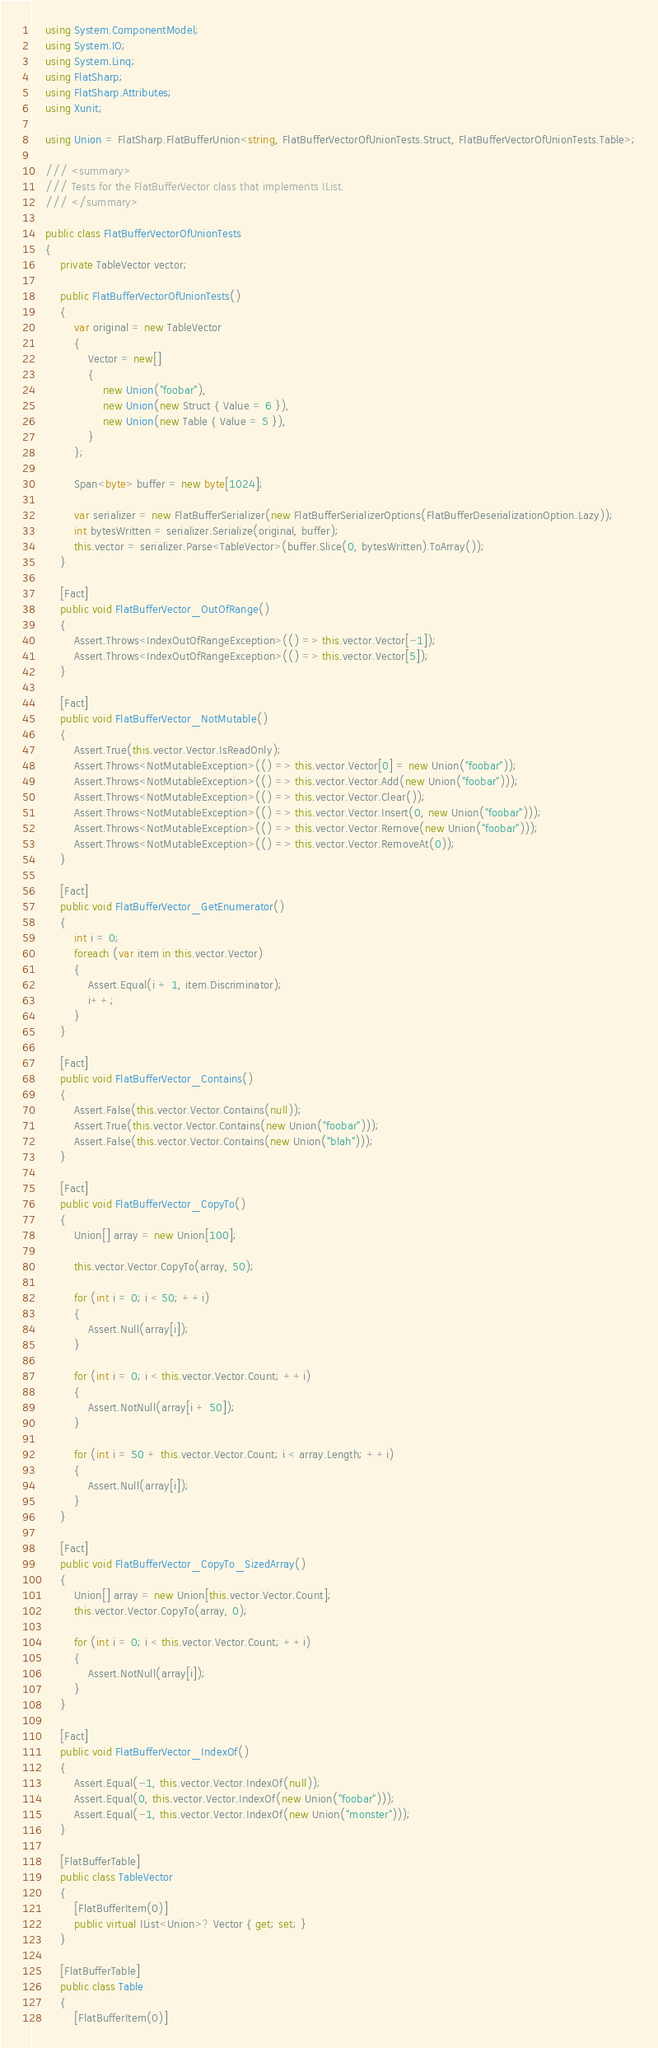<code> <loc_0><loc_0><loc_500><loc_500><_C#_>    using System.ComponentModel;
    using System.IO;
    using System.Linq;
    using FlatSharp;
    using FlatSharp.Attributes;
    using Xunit;

    using Union = FlatSharp.FlatBufferUnion<string, FlatBufferVectorOfUnionTests.Struct, FlatBufferVectorOfUnionTests.Table>;

    /// <summary>
    /// Tests for the FlatBufferVector class that implements IList.
    /// </summary>
    
    public class FlatBufferVectorOfUnionTests
    {
        private TableVector vector;

        public FlatBufferVectorOfUnionTests()
        {
            var original = new TableVector
            {
                Vector = new[]
                {
                    new Union("foobar"),
                    new Union(new Struct { Value = 6 }),
                    new Union(new Table { Value = 5 }),
                }
            };

            Span<byte> buffer = new byte[1024];

            var serializer = new FlatBufferSerializer(new FlatBufferSerializerOptions(FlatBufferDeserializationOption.Lazy));
            int bytesWritten = serializer.Serialize(original, buffer);
            this.vector = serializer.Parse<TableVector>(buffer.Slice(0, bytesWritten).ToArray());
        }

        [Fact]
        public void FlatBufferVector_OutOfRange()
        {
            Assert.Throws<IndexOutOfRangeException>(() => this.vector.Vector[-1]);
            Assert.Throws<IndexOutOfRangeException>(() => this.vector.Vector[5]);
        }

        [Fact]
        public void FlatBufferVector_NotMutable()
        {
            Assert.True(this.vector.Vector.IsReadOnly);
            Assert.Throws<NotMutableException>(() => this.vector.Vector[0] = new Union("foobar"));
            Assert.Throws<NotMutableException>(() => this.vector.Vector.Add(new Union("foobar")));
            Assert.Throws<NotMutableException>(() => this.vector.Vector.Clear());
            Assert.Throws<NotMutableException>(() => this.vector.Vector.Insert(0, new Union("foobar")));
            Assert.Throws<NotMutableException>(() => this.vector.Vector.Remove(new Union("foobar")));
            Assert.Throws<NotMutableException>(() => this.vector.Vector.RemoveAt(0));
        }

        [Fact]
        public void FlatBufferVector_GetEnumerator()
        {
            int i = 0; 
            foreach (var item in this.vector.Vector)
            {
                Assert.Equal(i + 1, item.Discriminator);
                i++;
            }
        }

        [Fact]
        public void FlatBufferVector_Contains()
        {
            Assert.False(this.vector.Vector.Contains(null));
            Assert.True(this.vector.Vector.Contains(new Union("foobar")));
            Assert.False(this.vector.Vector.Contains(new Union("blah")));
        }

        [Fact]
        public void FlatBufferVector_CopyTo()
        {
            Union[] array = new Union[100];

            this.vector.Vector.CopyTo(array, 50);
            
            for (int i = 0; i < 50; ++i)
            {
                Assert.Null(array[i]);
            }

            for (int i = 0; i < this.vector.Vector.Count; ++i)
            {
                Assert.NotNull(array[i + 50]);
            }

            for (int i = 50 + this.vector.Vector.Count; i < array.Length; ++i)
            {
                Assert.Null(array[i]);
            }
        }

        [Fact]
        public void FlatBufferVector_CopyTo_SizedArray()
        {
            Union[] array = new Union[this.vector.Vector.Count];
            this.vector.Vector.CopyTo(array, 0);

            for (int i = 0; i < this.vector.Vector.Count; ++i)
            {
                Assert.NotNull(array[i]);
            }
        }

        [Fact]
        public void FlatBufferVector_IndexOf()
        {
            Assert.Equal(-1, this.vector.Vector.IndexOf(null));
            Assert.Equal(0, this.vector.Vector.IndexOf(new Union("foobar")));
            Assert.Equal(-1, this.vector.Vector.IndexOf(new Union("monster")));
        }

        [FlatBufferTable]
        public class TableVector
        {
            [FlatBufferItem(0)]
            public virtual IList<Union>? Vector { get; set; }
        }

        [FlatBufferTable]
        public class Table
        {
            [FlatBufferItem(0)]</code> 